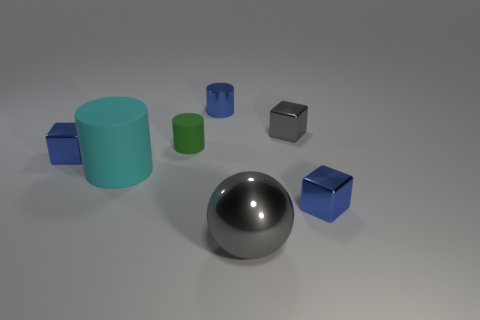Subtract all blue metallic cylinders. How many cylinders are left? 2 Subtract all green cylinders. How many blue blocks are left? 2 Add 2 tiny blue shiny blocks. How many objects exist? 9 Subtract all cyan cubes. Subtract all cyan cylinders. How many cubes are left? 3 Subtract all cubes. How many objects are left? 4 Add 3 small green matte things. How many small green matte things exist? 4 Subtract 1 green cylinders. How many objects are left? 6 Subtract all big metal objects. Subtract all shiny spheres. How many objects are left? 5 Add 6 green matte objects. How many green matte objects are left? 7 